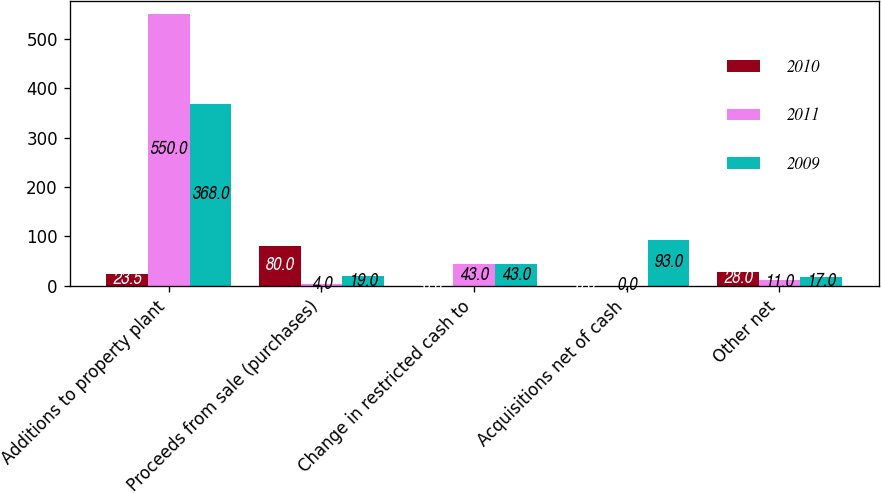<chart> <loc_0><loc_0><loc_500><loc_500><stacked_bar_chart><ecel><fcel>Additions to property plant<fcel>Proceeds from sale (purchases)<fcel>Change in restricted cash to<fcel>Acquisitions net of cash<fcel>Other net<nl><fcel>2010<fcel>23.5<fcel>80<fcel>0<fcel>0<fcel>28<nl><fcel>2011<fcel>550<fcel>4<fcel>43<fcel>0<fcel>11<nl><fcel>2009<fcel>368<fcel>19<fcel>43<fcel>93<fcel>17<nl></chart> 